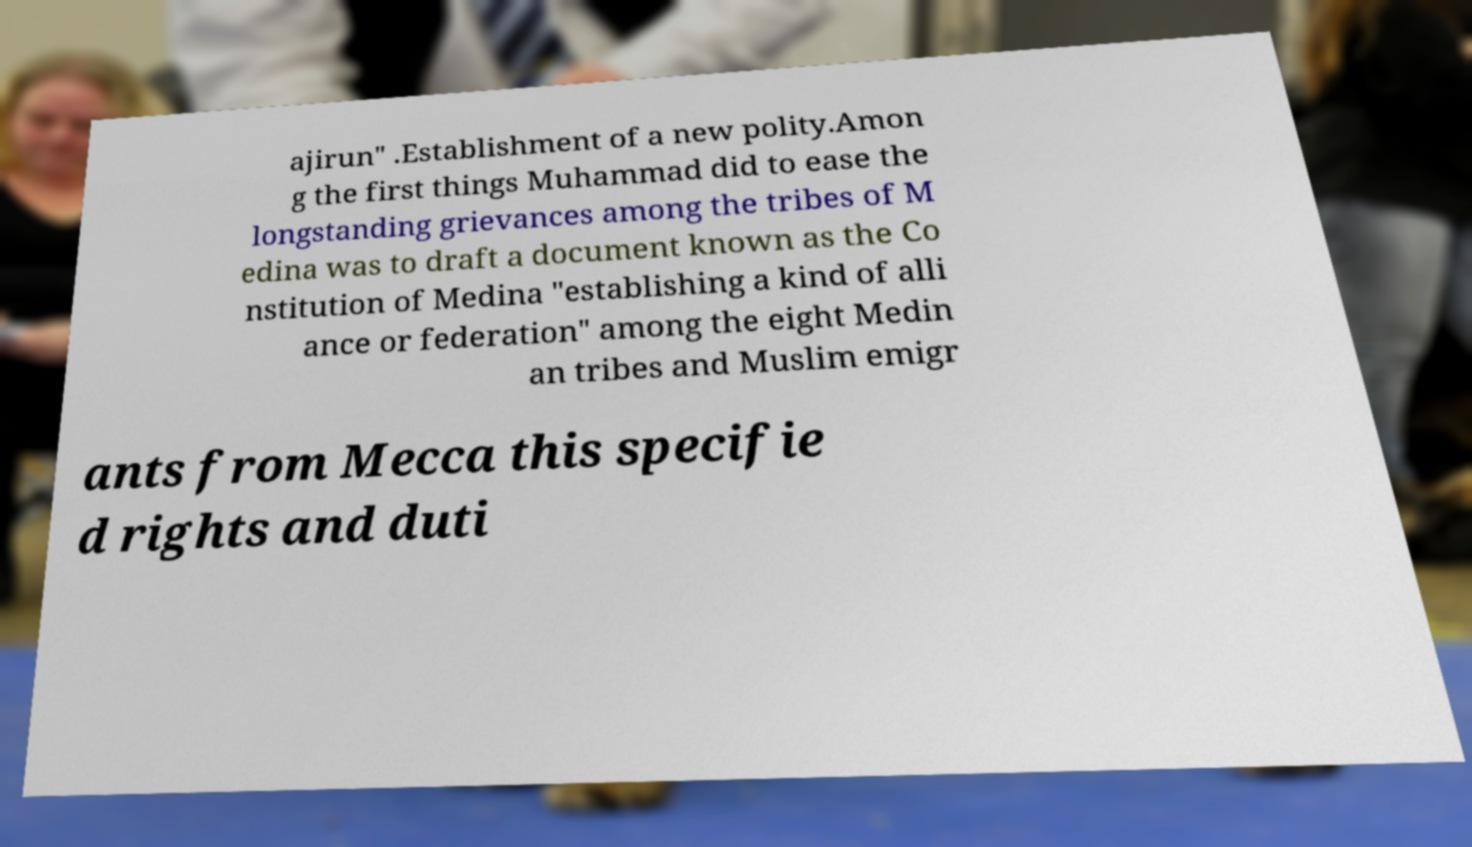There's text embedded in this image that I need extracted. Can you transcribe it verbatim? ajirun" .Establishment of a new polity.Amon g the first things Muhammad did to ease the longstanding grievances among the tribes of M edina was to draft a document known as the Co nstitution of Medina "establishing a kind of alli ance or federation" among the eight Medin an tribes and Muslim emigr ants from Mecca this specifie d rights and duti 